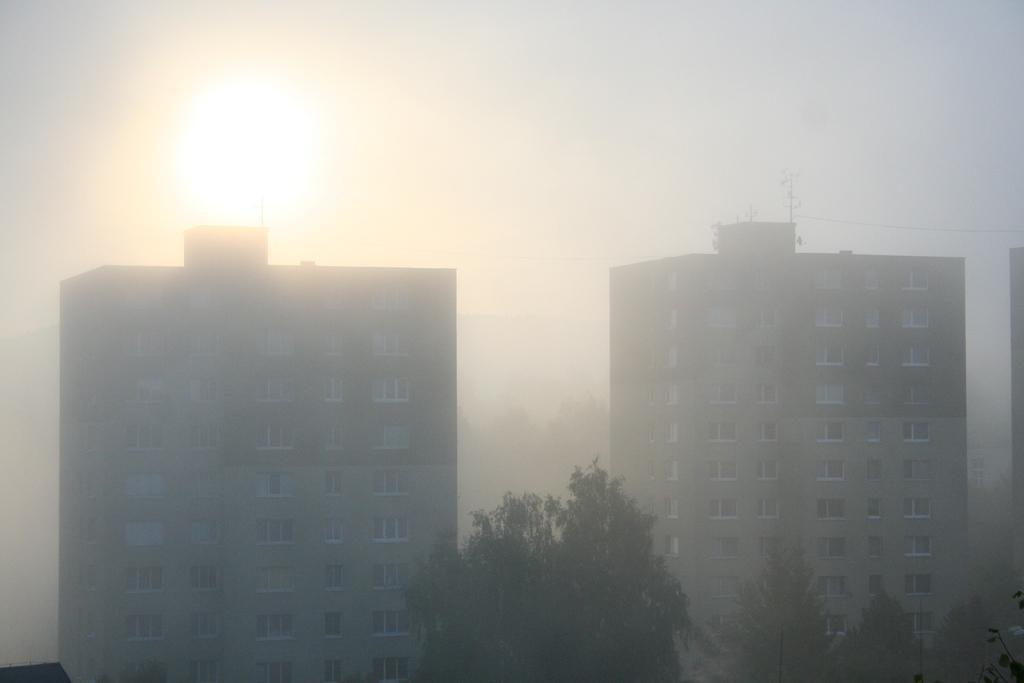Can you describe this image briefly? In this picture we can see two building with windows. In the center we can see the tree. On the top there is a foggy sky and sun. 